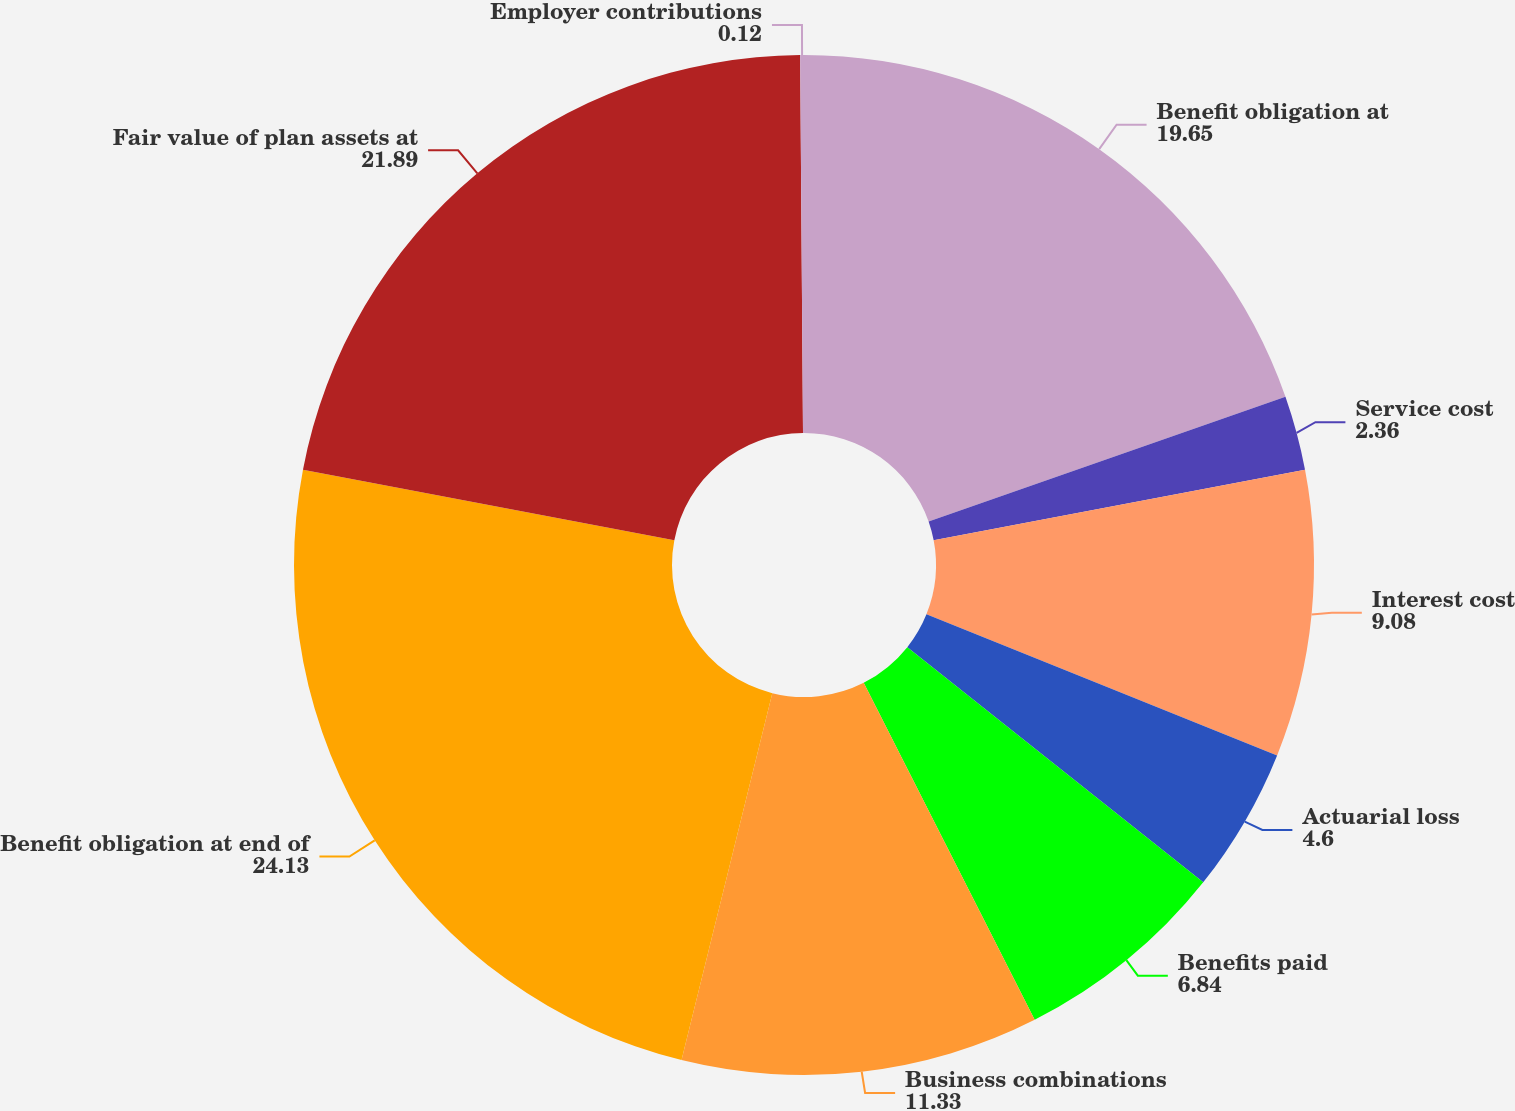Convert chart. <chart><loc_0><loc_0><loc_500><loc_500><pie_chart><fcel>Benefit obligation at<fcel>Service cost<fcel>Interest cost<fcel>Actuarial loss<fcel>Benefits paid<fcel>Business combinations<fcel>Benefit obligation at end of<fcel>Fair value of plan assets at<fcel>Employer contributions<nl><fcel>19.65%<fcel>2.36%<fcel>9.08%<fcel>4.6%<fcel>6.84%<fcel>11.33%<fcel>24.13%<fcel>21.89%<fcel>0.12%<nl></chart> 